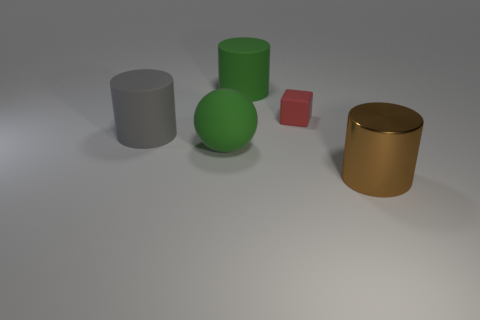Subtract all cyan cylinders. Subtract all purple balls. How many cylinders are left? 3 Add 3 gray rubber cylinders. How many objects exist? 8 Subtract all cylinders. How many objects are left? 2 Add 3 large matte cylinders. How many large matte cylinders are left? 5 Add 4 big gray objects. How many big gray objects exist? 5 Subtract 0 yellow spheres. How many objects are left? 5 Subtract all green spheres. Subtract all shiny cylinders. How many objects are left? 3 